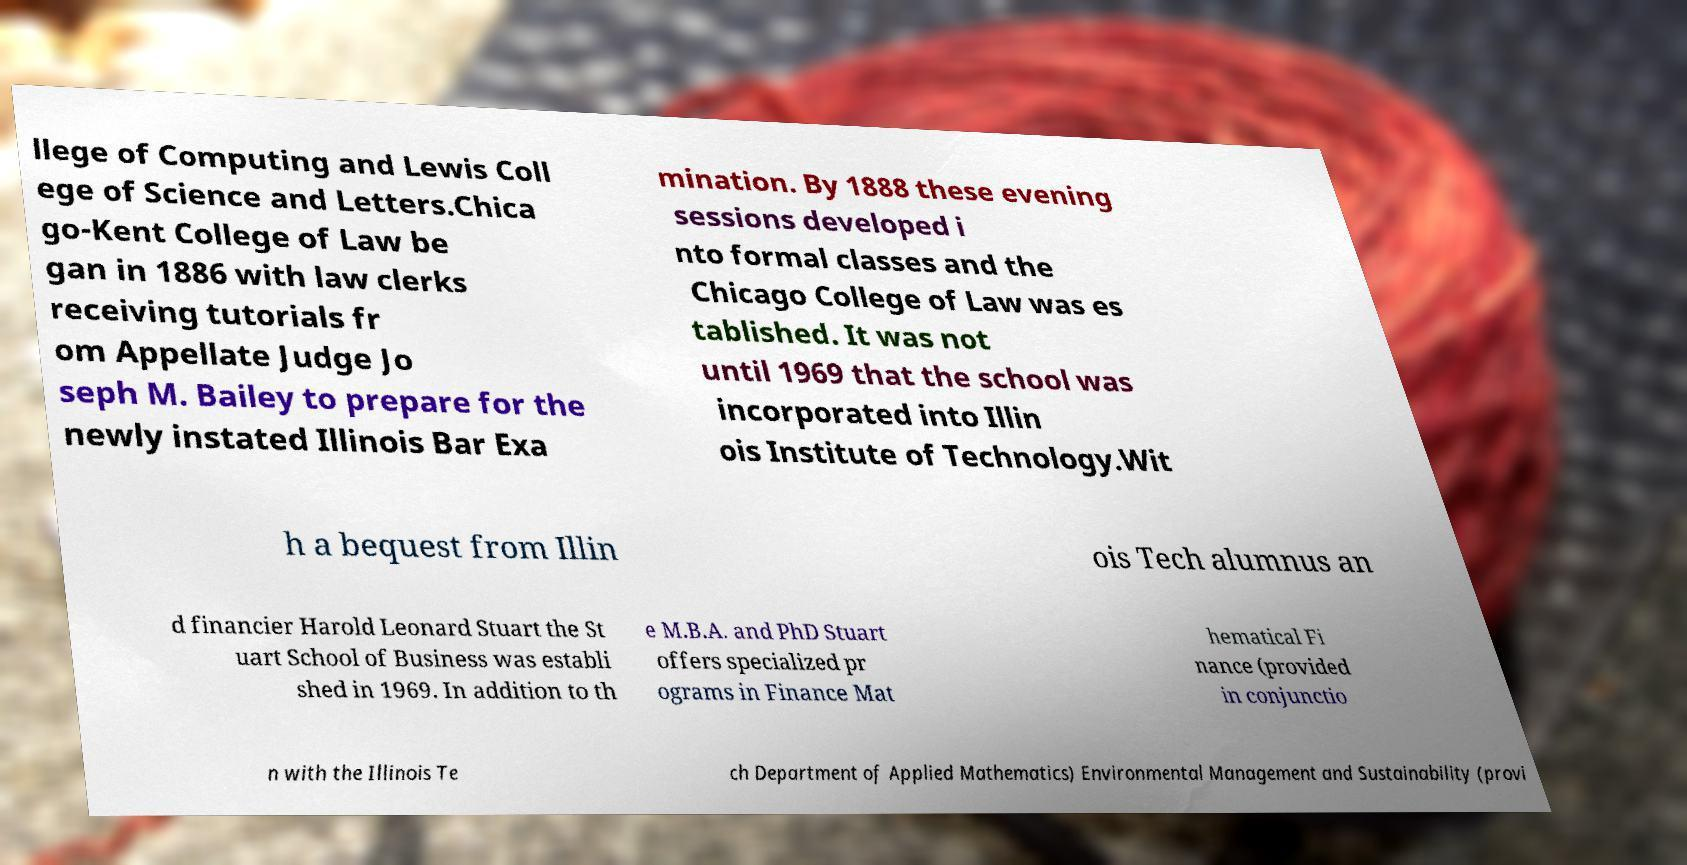For documentation purposes, I need the text within this image transcribed. Could you provide that? llege of Computing and Lewis Coll ege of Science and Letters.Chica go-Kent College of Law be gan in 1886 with law clerks receiving tutorials fr om Appellate Judge Jo seph M. Bailey to prepare for the newly instated Illinois Bar Exa mination. By 1888 these evening sessions developed i nto formal classes and the Chicago College of Law was es tablished. It was not until 1969 that the school was incorporated into Illin ois Institute of Technology.Wit h a bequest from Illin ois Tech alumnus an d financier Harold Leonard Stuart the St uart School of Business was establi shed in 1969. In addition to th e M.B.A. and PhD Stuart offers specialized pr ograms in Finance Mat hematical Fi nance (provided in conjunctio n with the Illinois Te ch Department of Applied Mathematics) Environmental Management and Sustainability (provi 